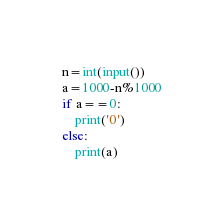Convert code to text. <code><loc_0><loc_0><loc_500><loc_500><_Python_>n=int(input())
a=1000-n%1000
if a==0:
    print('0')
else:
    print(a)
</code> 